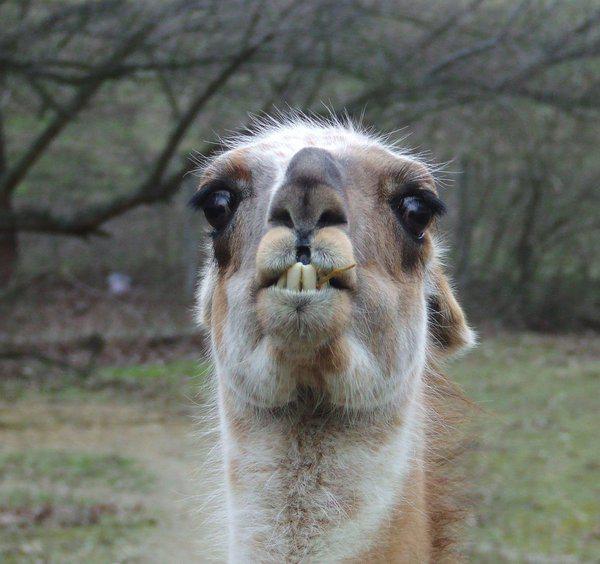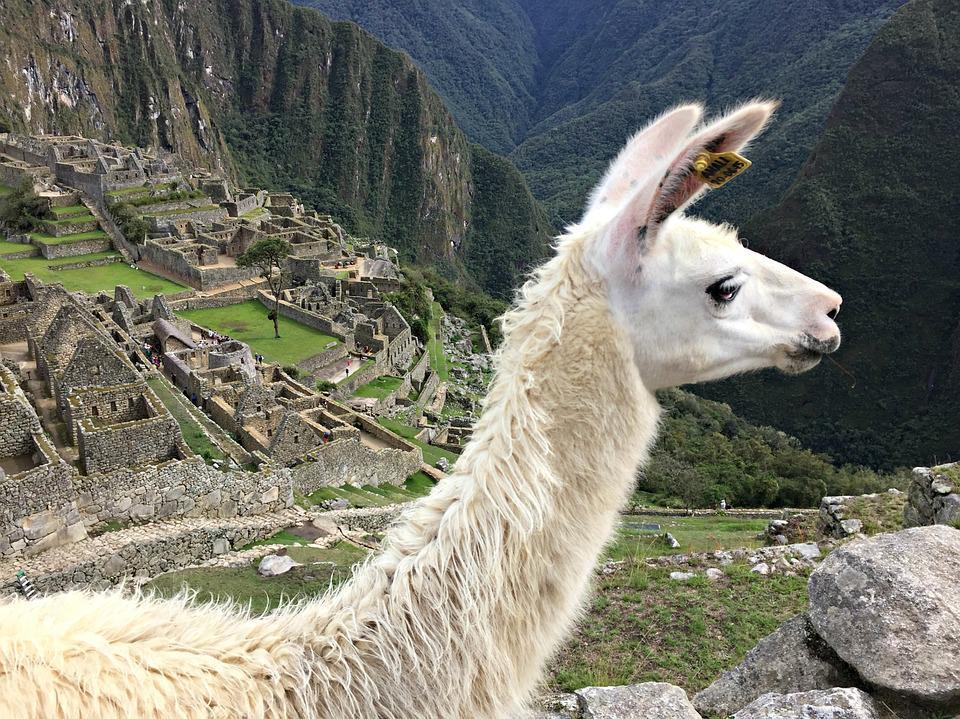The first image is the image on the left, the second image is the image on the right. Examine the images to the left and right. Is the description "There are exactly two llamas." accurate? Answer yes or no. Yes. 